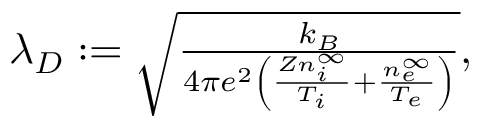<formula> <loc_0><loc_0><loc_500><loc_500>\begin{array} { r } { \lambda _ { D } \colon = \sqrt { \frac { k _ { B } } { 4 \pi e ^ { 2 } \left ( \frac { Z n _ { i } ^ { \infty } } { T _ { i } } + \frac { n _ { e } ^ { \infty } } { T _ { e } } \right ) } } , } \end{array}</formula> 